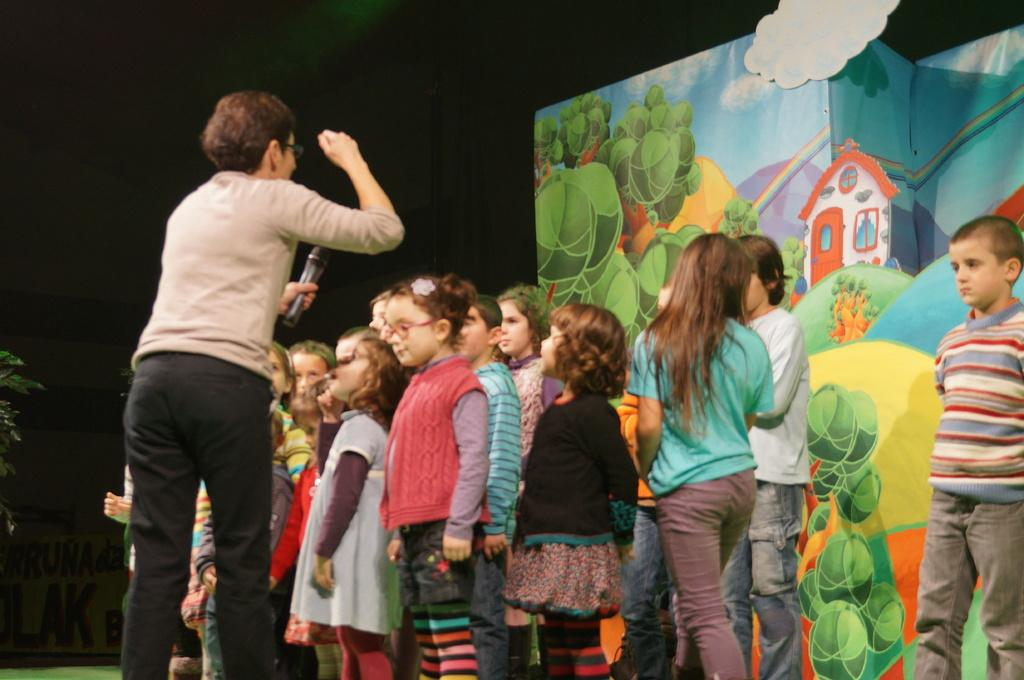How many kids are in the image? There are kids in the image, but the exact number is not specified. What are the women in the image doing? One woman is holding a microphone, but the actions of the other women are not mentioned. What can be seen in the background of the image? There are decorative objects, a dark view, plant leaves, and a banner visible in the background. What is the father doing in the image? There is no mention of a father in the image, so it is not possible to answer this question. 